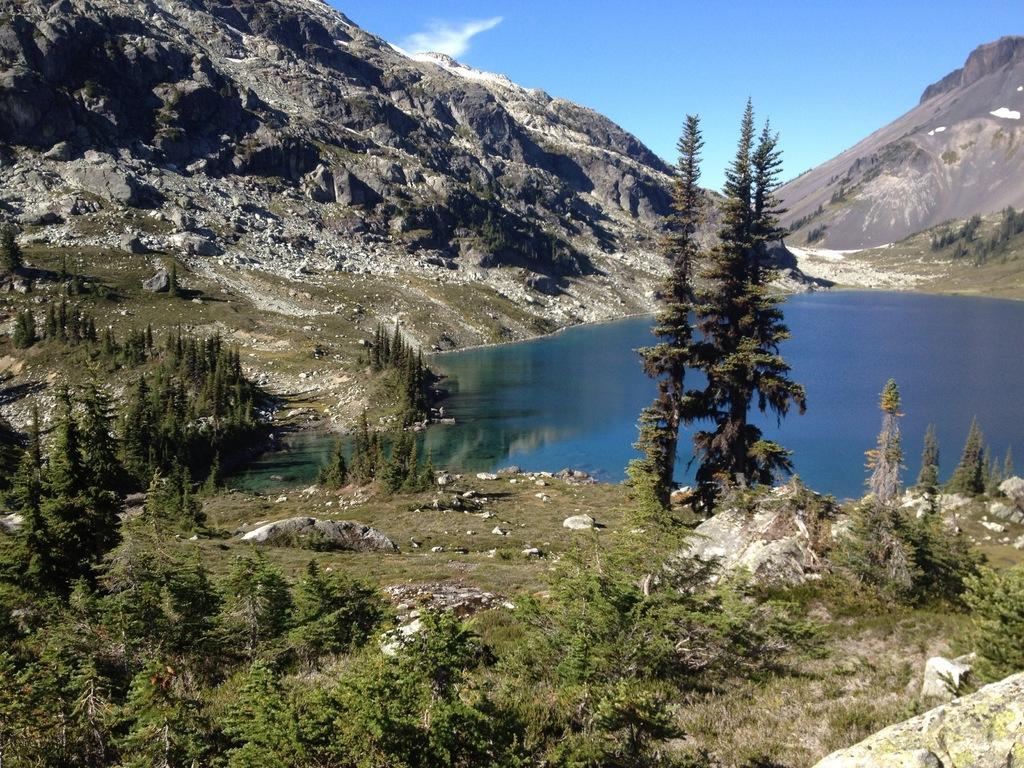Please provide a concise description of this image. In this image, we can see some hills. We can see the ground. We can see some grass, plants, rocks and trees. We can see some water. We can see the sky with clouds. We can see the reflection of the plants in the water. 